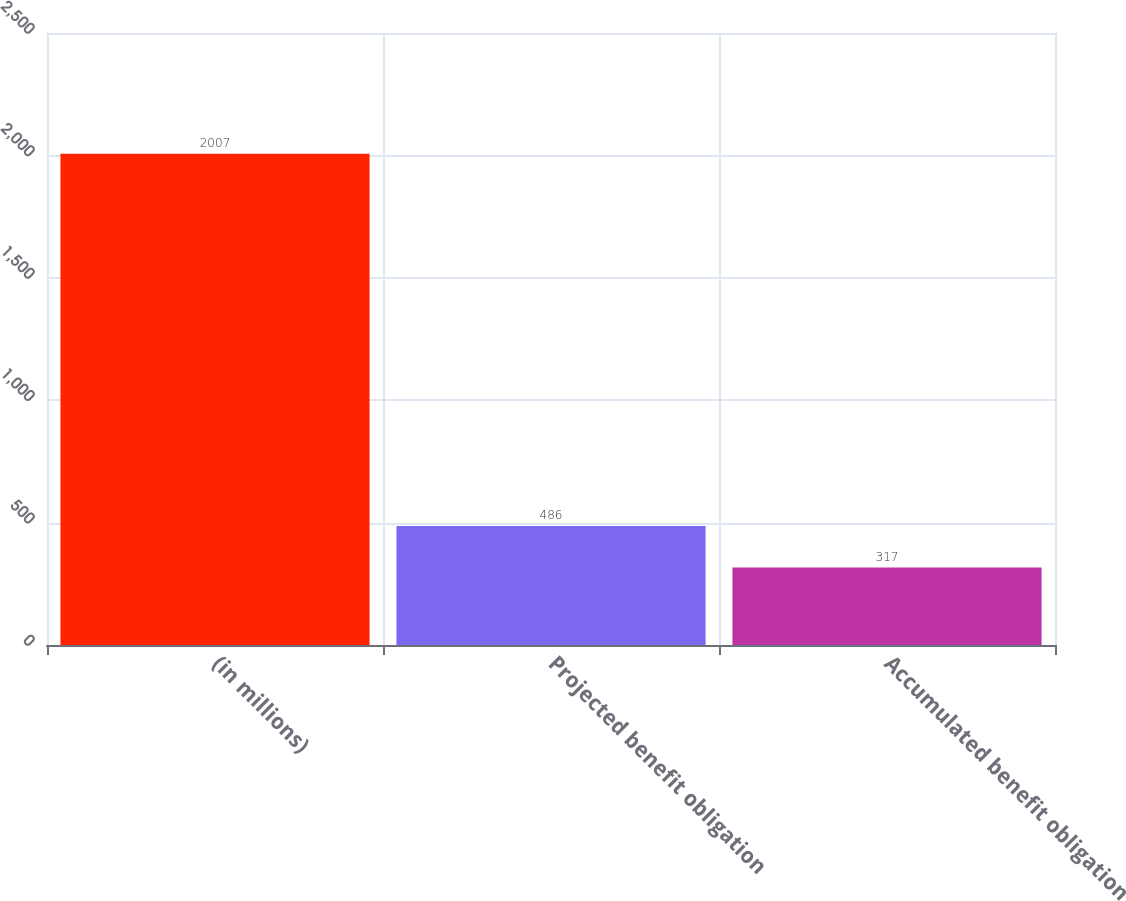Convert chart to OTSL. <chart><loc_0><loc_0><loc_500><loc_500><bar_chart><fcel>(in millions)<fcel>Projected benefit obligation<fcel>Accumulated benefit obligation<nl><fcel>2007<fcel>486<fcel>317<nl></chart> 